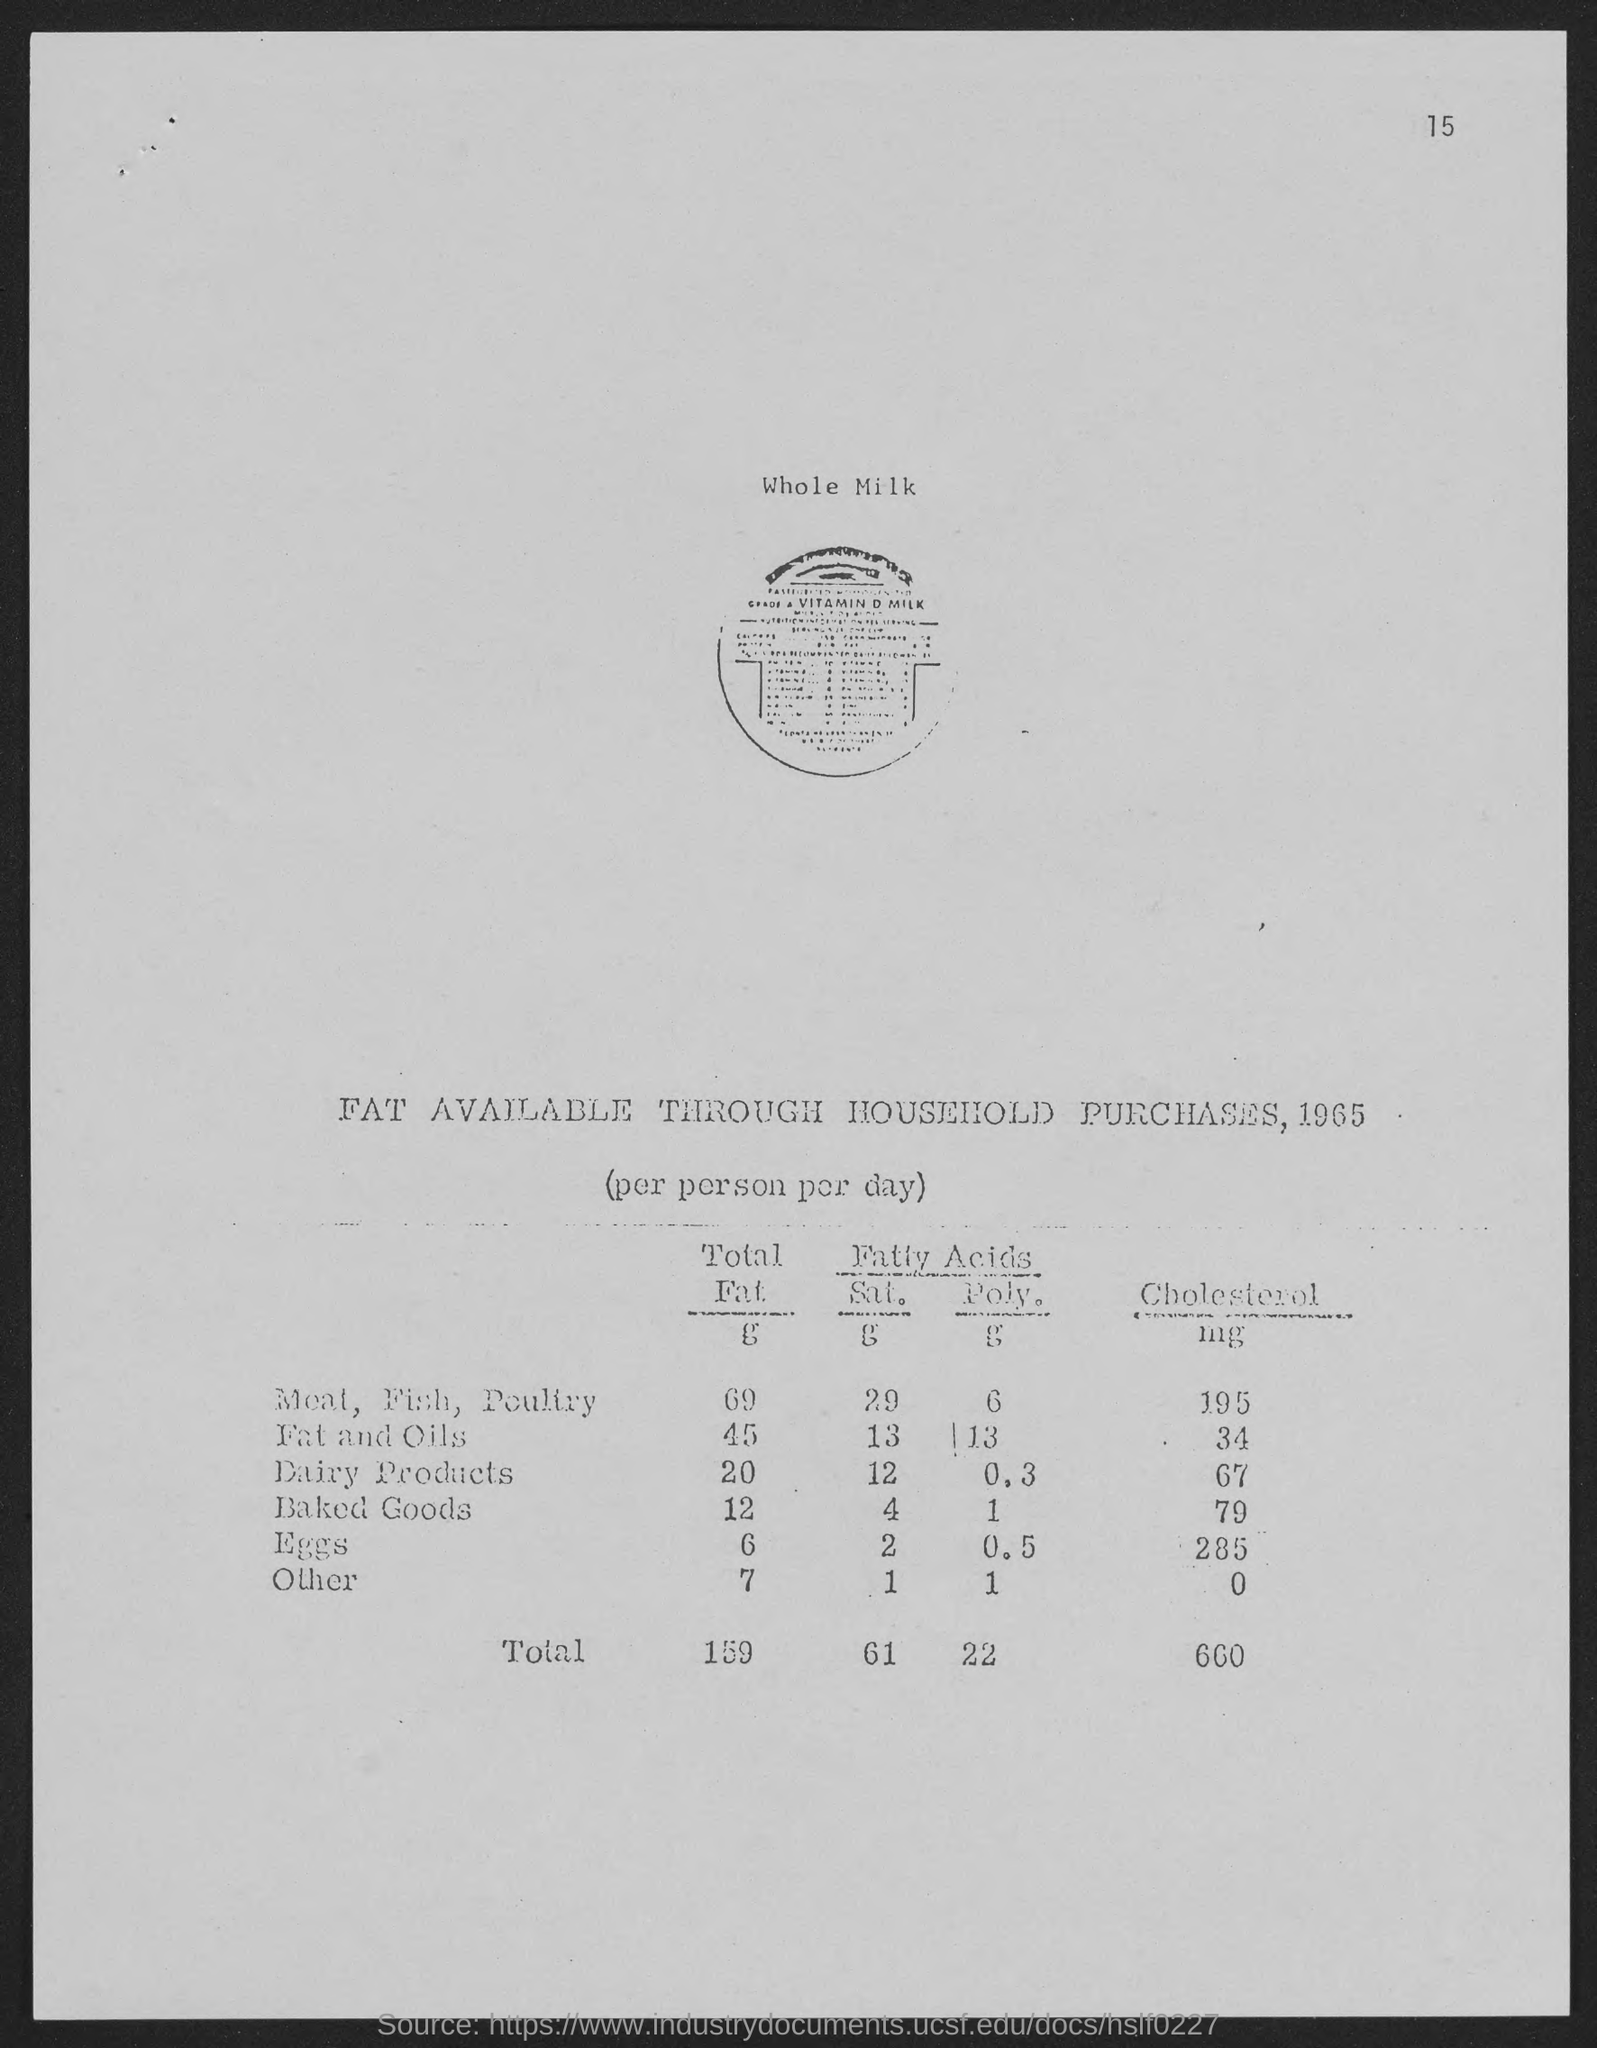What is the page number?
Provide a short and direct response. 15. When was the data in the document compiled?
Make the answer very short. 1965. Which product in the list has the highest cholestrol?
Offer a very short reply. Eggs. Which product has total fat of 12?
Give a very brief answer. Baked Goods. What is mentioned in the first line of the document?
Offer a very short reply. Whole Milk. What is the total fat for dairy products?
Ensure brevity in your answer.  20. What has higher cholestrol, dairy products or baked goods?
Make the answer very short. Baked Goods. What is the total value of cholestrol?
Give a very brief answer. 660. What is the total value in the third column?
Make the answer very short. 22. 